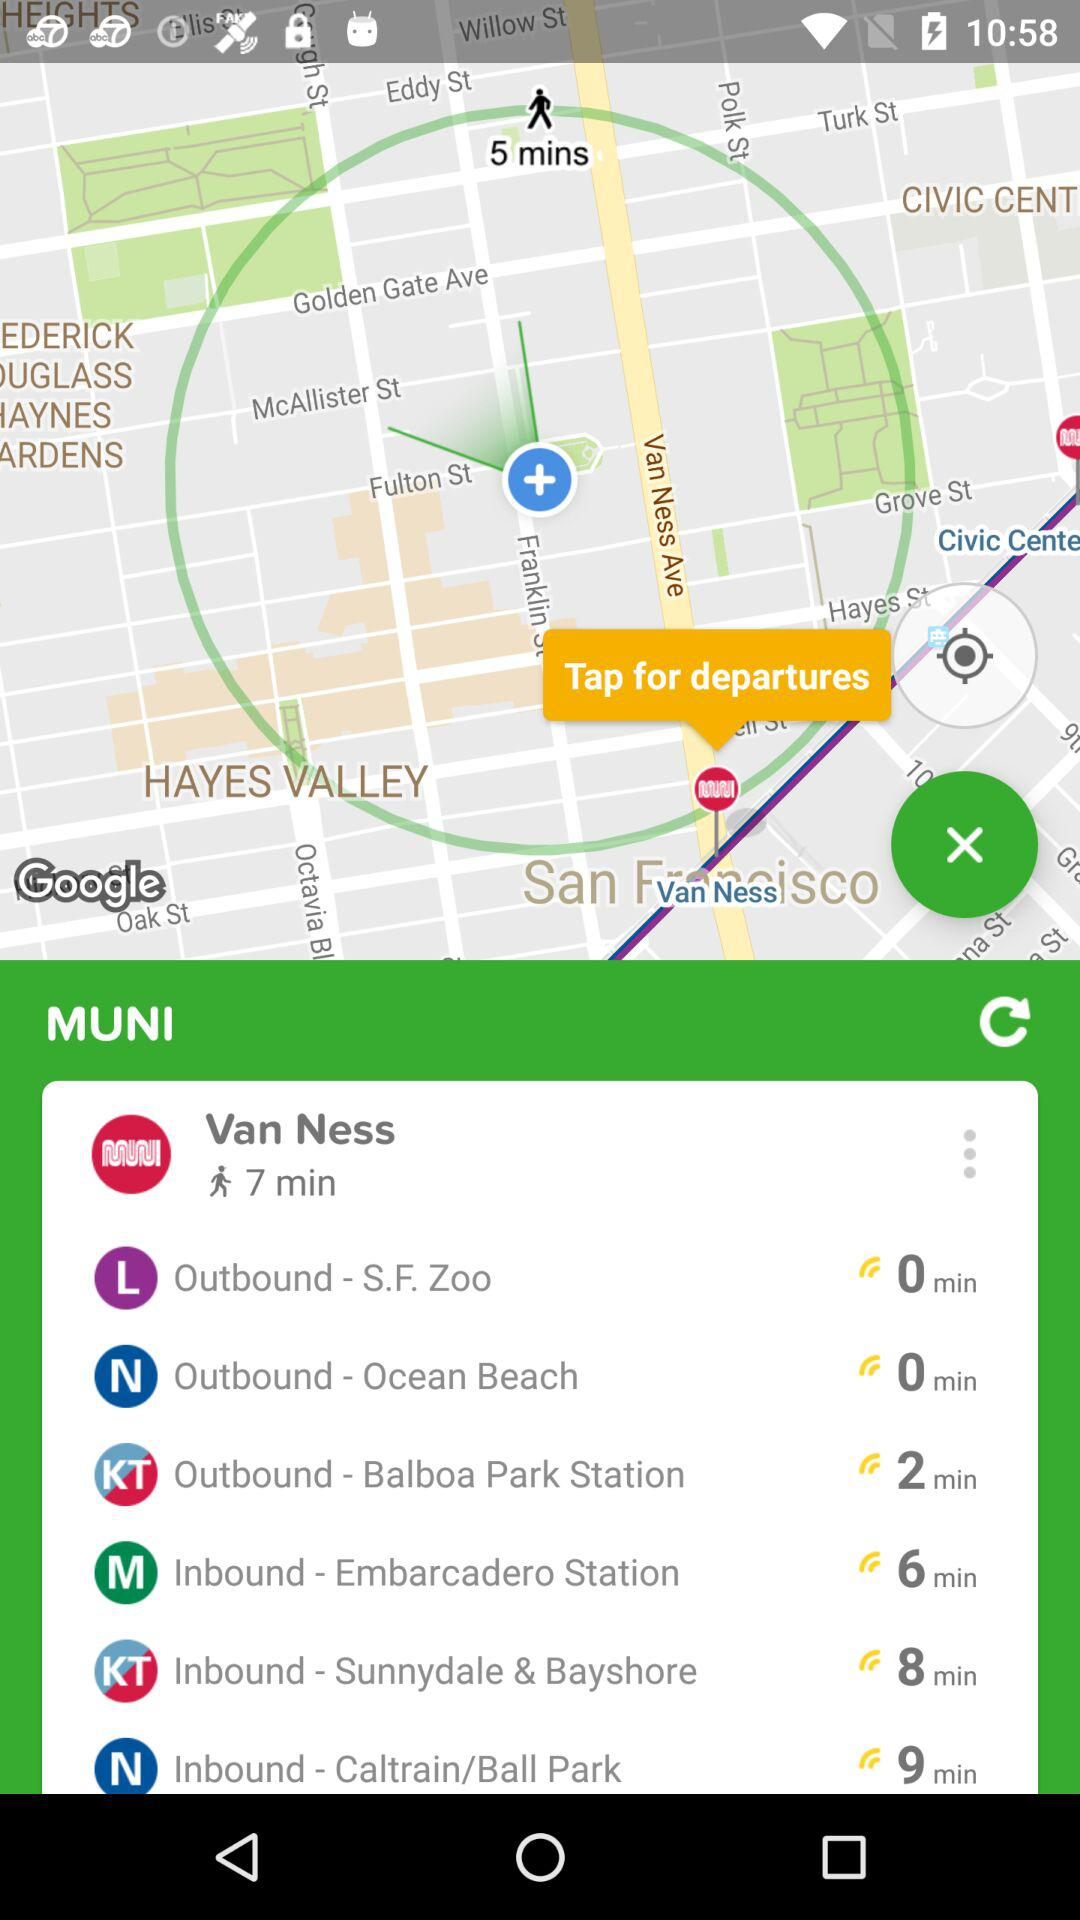Which has the 0 min of distance by waking?
When the provided information is insufficient, respond with <no answer>. <no answer> 